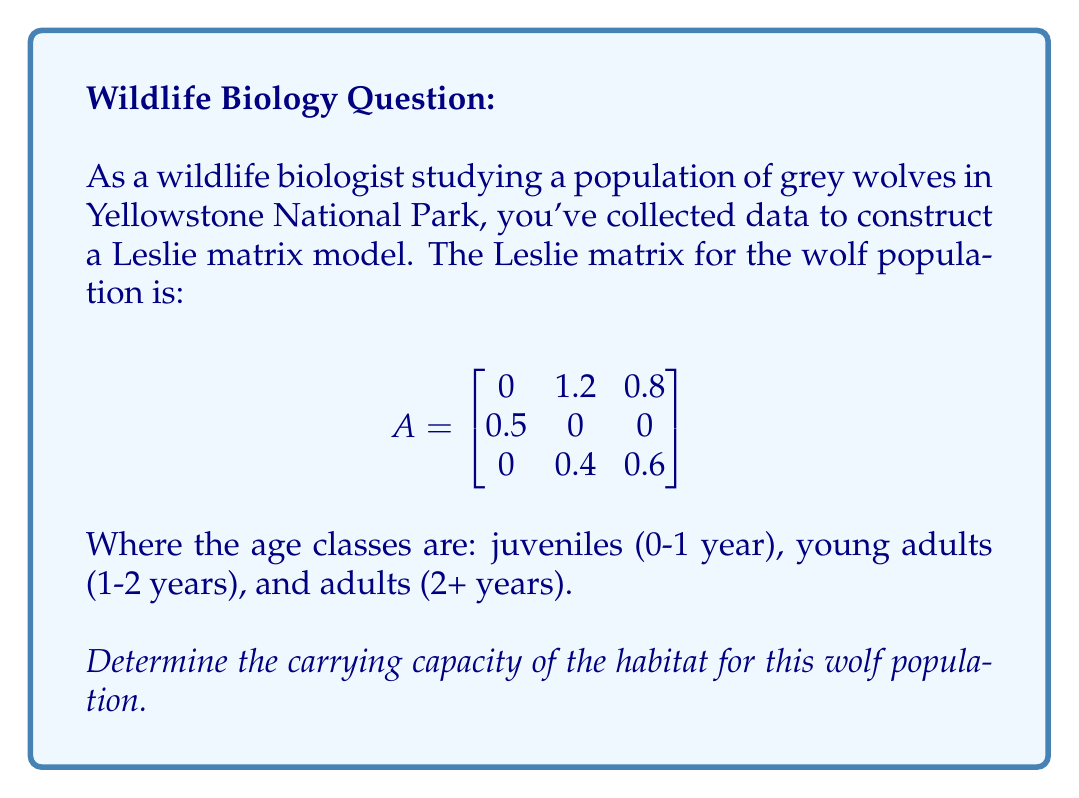Solve this math problem. To determine the carrying capacity using a Leslie matrix, we need to follow these steps:

1) Find the dominant eigenvalue (λ) of the Leslie matrix. This represents the long-term growth rate of the population.

2) If λ > 1, the population will grow; if λ < 1, it will decline; if λ = 1, it will stabilize.

3) The carrying capacity is reached when λ = 1.

Let's solve:

1) To find the eigenvalues, we solve the characteristic equation:
   $$det(A - λI) = 0$$

   $$\begin{vmatrix}
   -λ & 1.2 & 0.8 \\
   0.5 & -λ & 0 \\
   0 & 0.4 & 0.6-λ
   \end{vmatrix} = 0$$

2) Expanding the determinant:
   $$-λ((-λ)(0.6-λ) - 0) + 1.2(0.5(0.6-λ) - 0) + 0.8(0.5(0.4) - 0) = 0$$
   $$-λ(-0.6λ + λ^2) + 0.6λ - 0.3λ^2 + 0.16 = 0$$
   $$0.6λ^2 - λ^3 + 0.6λ - 0.3λ^2 + 0.16 = 0$$
   $$-λ^3 + 0.3λ^2 + 0.6λ + 0.16 = 0$$

3) Solving this cubic equation (using a calculator or computer algebra system) gives:
   λ ≈ 1.2, -0.45 + 0.56i, -0.45 - 0.56i

4) The dominant eigenvalue is λ ≈ 1.2 > 1, indicating the population is growing.

5) To find the carrying capacity, we need to adjust the Leslie matrix so that λ = 1. This is typically done by reducing the fecundity rates (top row of the matrix) proportionally.

6) Let's introduce a factor k to reduce the fecundity rates:

   $$A_k = \begin{bmatrix}
   0 & 1.2k & 0.8k \\
   0.5 & 0 & 0 \\
   0 & 0.4 & 0.6
   \end{bmatrix}$$

7) We need to find k such that the dominant eigenvalue of A_k is 1. This can be done iteratively or using optimization techniques. The result is approximately k ≈ 0.833.

8) The carrying capacity Leslie matrix is therefore:

   $$A_{capacity} = \begin{bmatrix}
   0 & 1 & 0.67 \\
   0.5 & 0 & 0 \\
   0 & 0.4 & 0.6
   \end{bmatrix}$$

9) The stable age distribution (right eigenvector) of this matrix gives the population structure at carrying capacity. Solving $(A_{capacity} - I)v = 0$, we get:
   v ≈ [0.45, 0.23, 0.32]

10) If we normalize this to sum to 100 (for percentage), we get:
    [45%, 23%, 32%]

This means at carrying capacity, the population will consist of approximately 45% juveniles, 23% young adults, and 32% adults.
Answer: Carrying capacity: 45% juveniles, 23% young adults, 32% adults 